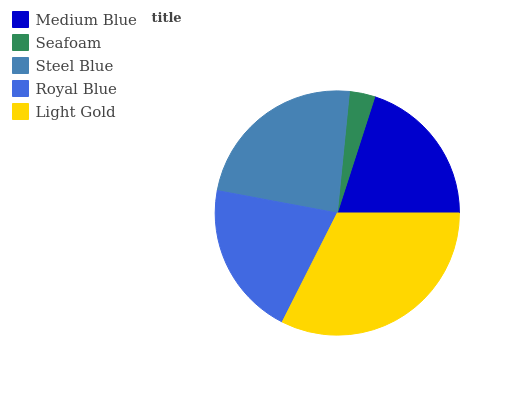Is Seafoam the minimum?
Answer yes or no. Yes. Is Light Gold the maximum?
Answer yes or no. Yes. Is Steel Blue the minimum?
Answer yes or no. No. Is Steel Blue the maximum?
Answer yes or no. No. Is Steel Blue greater than Seafoam?
Answer yes or no. Yes. Is Seafoam less than Steel Blue?
Answer yes or no. Yes. Is Seafoam greater than Steel Blue?
Answer yes or no. No. Is Steel Blue less than Seafoam?
Answer yes or no. No. Is Royal Blue the high median?
Answer yes or no. Yes. Is Royal Blue the low median?
Answer yes or no. Yes. Is Steel Blue the high median?
Answer yes or no. No. Is Steel Blue the low median?
Answer yes or no. No. 